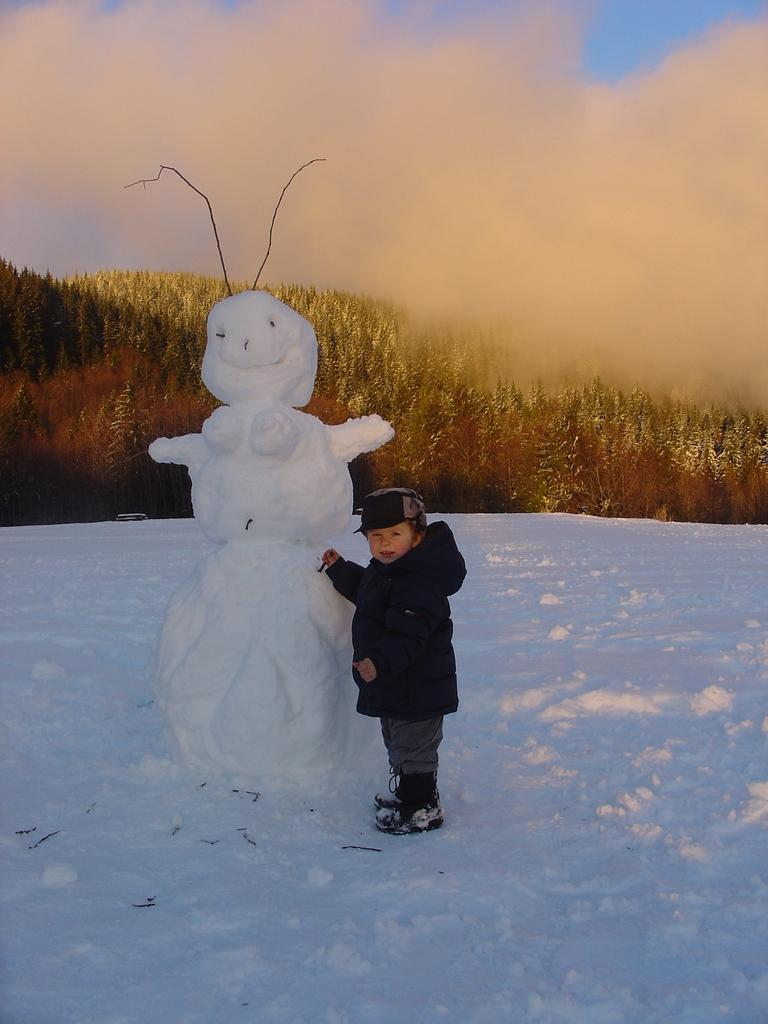Who is present in the image? There is a boy in the image. What is located beside the boy? There is a snowman beside the boy. What type of vegetation can be seen in the image? There are trees in the image. What is visible in the background of the image? The sky is visible in the image. What is the ground covered with in the image? There is snow in the image. What shape is the cannon in the image? There is no cannon present in the image. 